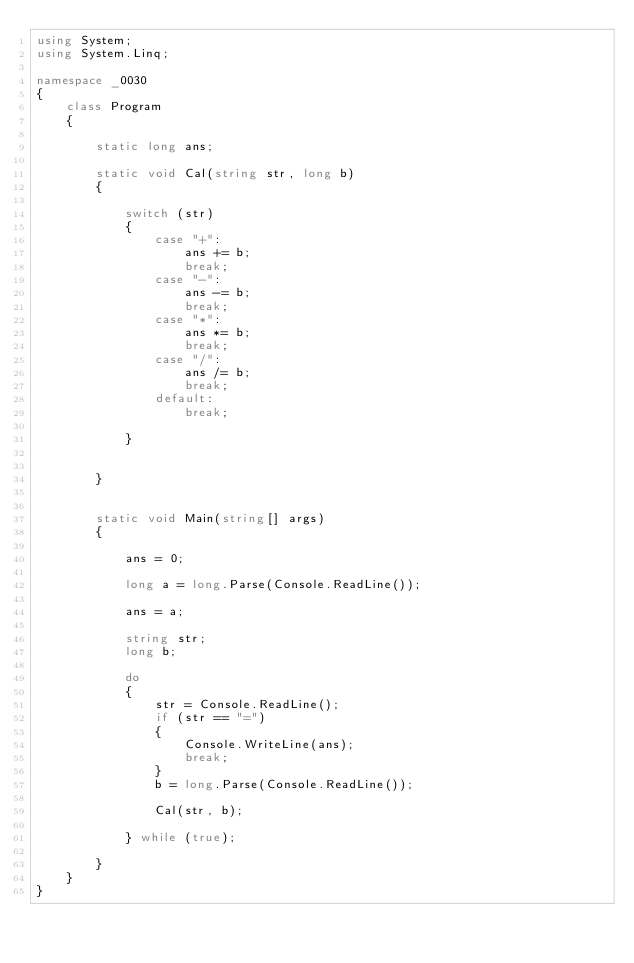Convert code to text. <code><loc_0><loc_0><loc_500><loc_500><_C#_>using System;
using System.Linq;

namespace _0030
{
    class Program
    {

        static long ans;

        static void Cal(string str, long b)
        {

            switch (str)
            {
                case "+":
                    ans += b;
                    break;
                case "-":
                    ans -= b;
                    break;
                case "*":
                    ans *= b;
                    break;
                case "/":
                    ans /= b;
                    break;
                default:                   
                    break;

            }

           
        }


        static void Main(string[] args)
        {

            ans = 0;

            long a = long.Parse(Console.ReadLine());

            ans = a;

            string str;
            long b;

            do
            {
                str = Console.ReadLine();
                if (str == "=")
                {
                    Console.WriteLine(ans);
                    break;
                }
                b = long.Parse(Console.ReadLine());

                Cal(str, b);

            } while (true);
         
        }
    }
}
</code> 